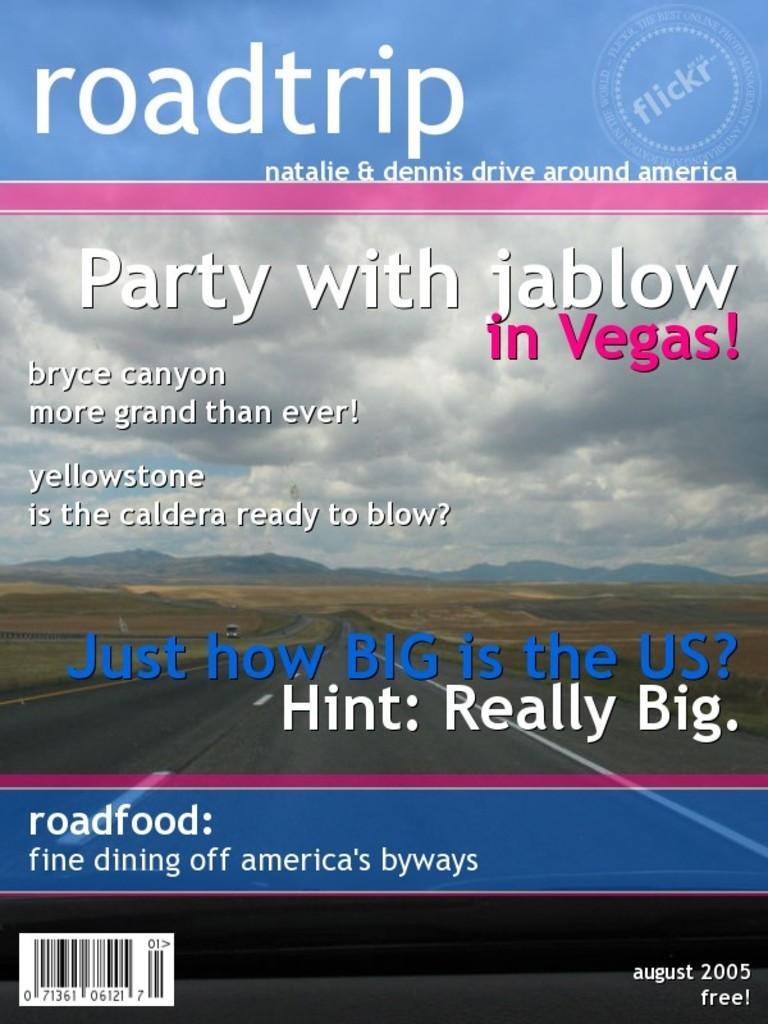<image>
Write a terse but informative summary of the picture. Roadtrip magazine from August 2005 asks Just how Big is the US, Hing: Really Big. 